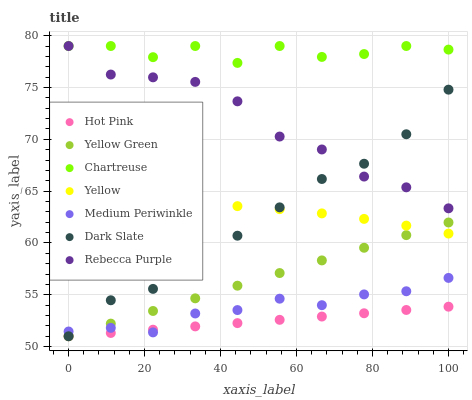Does Hot Pink have the minimum area under the curve?
Answer yes or no. Yes. Does Chartreuse have the maximum area under the curve?
Answer yes or no. Yes. Does Medium Periwinkle have the minimum area under the curve?
Answer yes or no. No. Does Medium Periwinkle have the maximum area under the curve?
Answer yes or no. No. Is Hot Pink the smoothest?
Answer yes or no. Yes. Is Chartreuse the roughest?
Answer yes or no. Yes. Is Medium Periwinkle the smoothest?
Answer yes or no. No. Is Medium Periwinkle the roughest?
Answer yes or no. No. Does Yellow Green have the lowest value?
Answer yes or no. Yes. Does Medium Periwinkle have the lowest value?
Answer yes or no. No. Does Rebecca Purple have the highest value?
Answer yes or no. Yes. Does Medium Periwinkle have the highest value?
Answer yes or no. No. Is Hot Pink less than Rebecca Purple?
Answer yes or no. Yes. Is Chartreuse greater than Yellow Green?
Answer yes or no. Yes. Does Medium Periwinkle intersect Dark Slate?
Answer yes or no. Yes. Is Medium Periwinkle less than Dark Slate?
Answer yes or no. No. Is Medium Periwinkle greater than Dark Slate?
Answer yes or no. No. Does Hot Pink intersect Rebecca Purple?
Answer yes or no. No. 